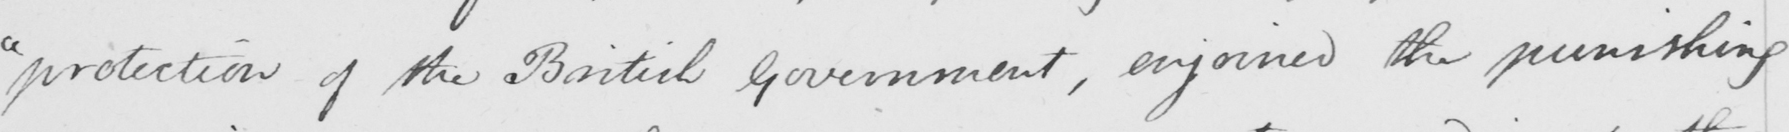Please provide the text content of this handwritten line. " protection of the British Government , enjoined the punishing 